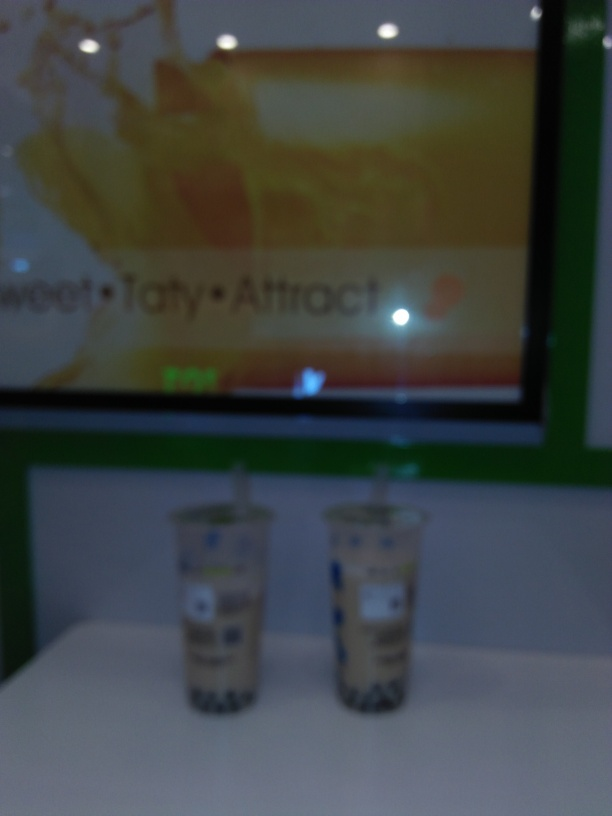Can you comment on the color scheme of the image? The image features a color palette with high contrast between the vivid green counter and the warm tones of the advertisement in the background. The beige color of the drinks adds a neutral element to this scheme. 